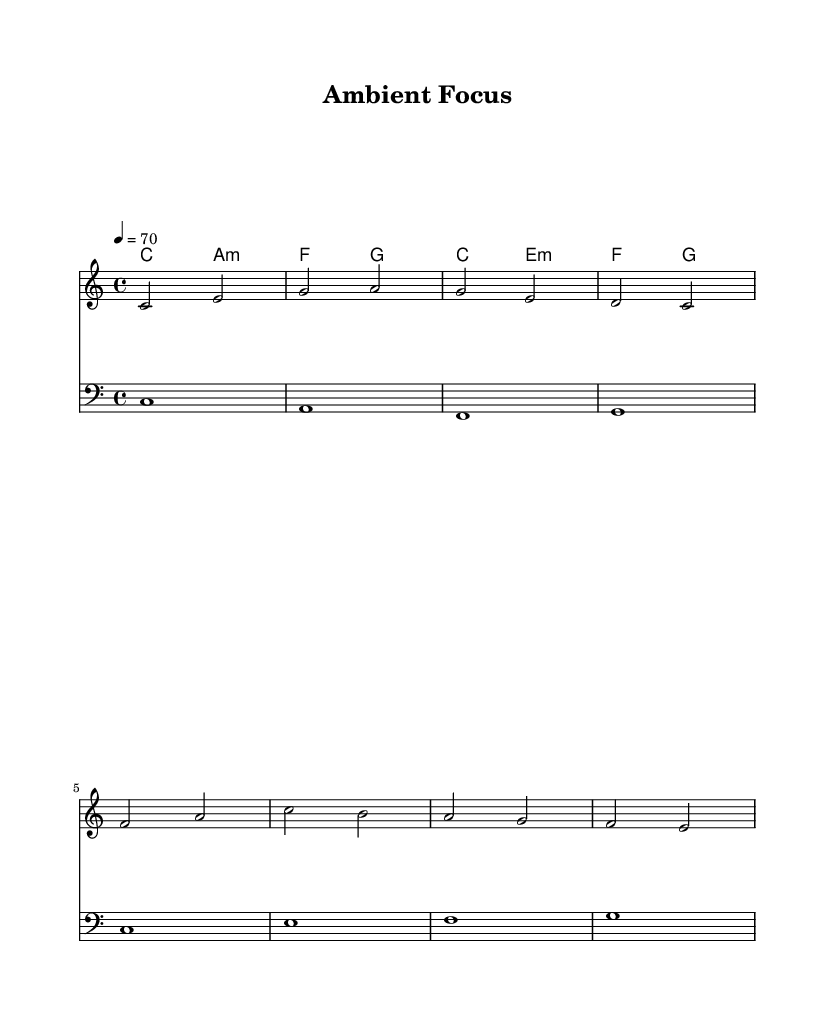What is the key signature of this music? The key signature is C major, which has no sharps or flats.
Answer: C major What is the time signature of this music? The time signature is indicated by the fraction at the beginning of the score, which shows that there are four beats in a measure and the quarter note gets one beat.
Answer: 4/4 What is the tempo marking for this piece? The tempo is indicated at the beginning of the score, which shows that it should be played at a speed of 70 beats per minute.
Answer: 70 How many measures are in the melody? The melody is broken down into sections marked by vertical lines on the staff, and counting these shows there are four measures present.
Answer: 4 What are the chords used in this arrangement? By locating the chord names above the staff, the chords present are C major, A minor, F major, and G major, which are listed in sequence.
Answer: C, A minor, F, G Which clef is used for the bass part? The bass part is indicated by a symbol on the staff, specifically a bass clef, which is used for lower-pitched notes.
Answer: Bass clef What is the highest note in the melody? Analyzing the melody notes on the staff shows that the highest note is A, located in the second measure at the top of the staff.
Answer: A 